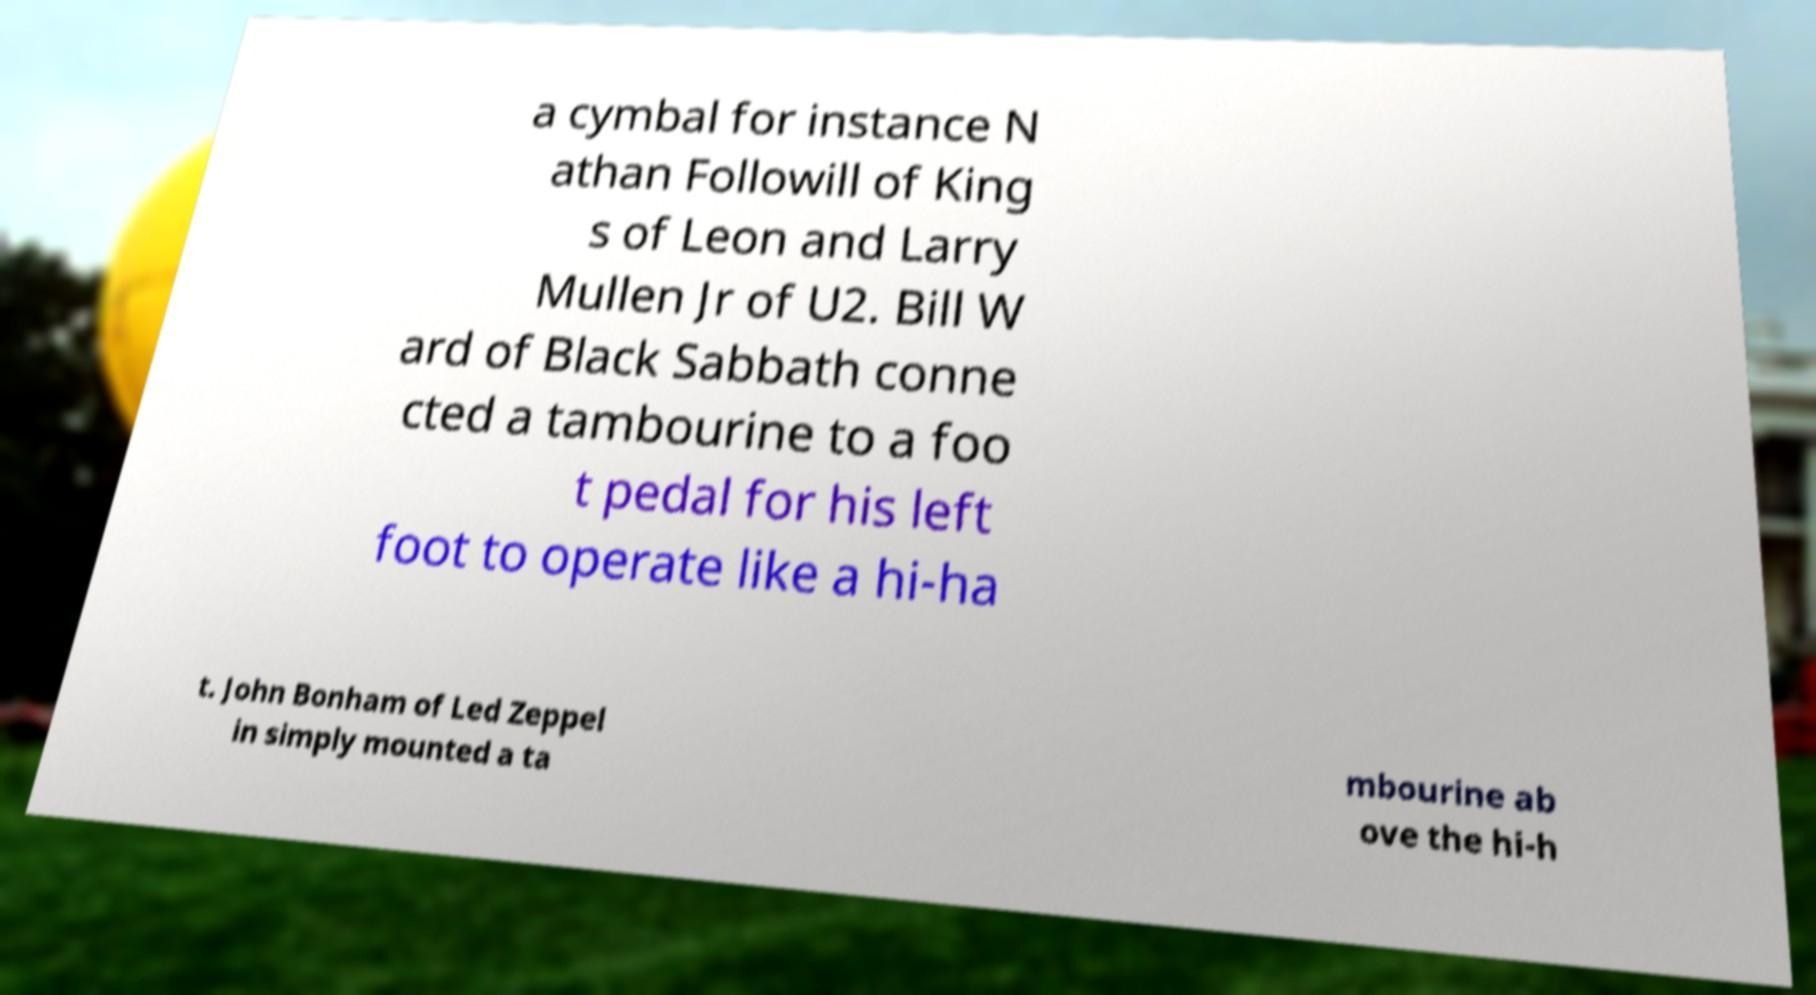Can you read and provide the text displayed in the image?This photo seems to have some interesting text. Can you extract and type it out for me? a cymbal for instance N athan Followill of King s of Leon and Larry Mullen Jr of U2. Bill W ard of Black Sabbath conne cted a tambourine to a foo t pedal for his left foot to operate like a hi-ha t. John Bonham of Led Zeppel in simply mounted a ta mbourine ab ove the hi-h 